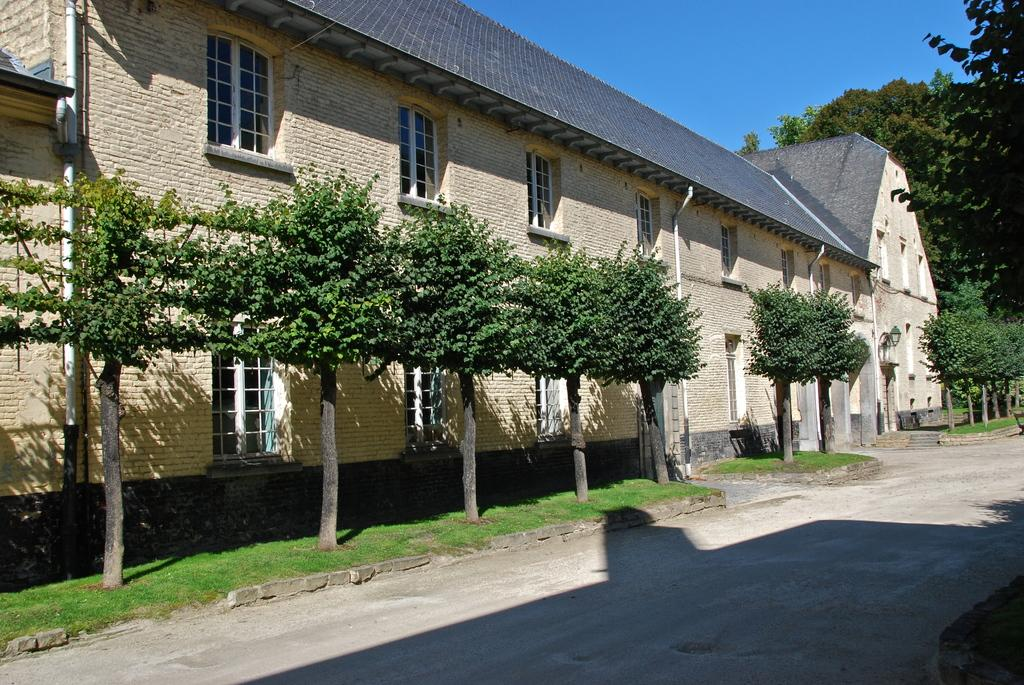What type of vegetation is present in the image? There are trees beside a wall and another tree on the right side of the image. What structure is visible in the image? There is a wall and a roof visible in the image. What is visible at the top of the image? The sky is visible at the top of the image. Where is the calendar located in the image? There is no calendar present in the image. What type of picture is hanging on the wall in the image? There is no picture hanging on the wall in the image. 